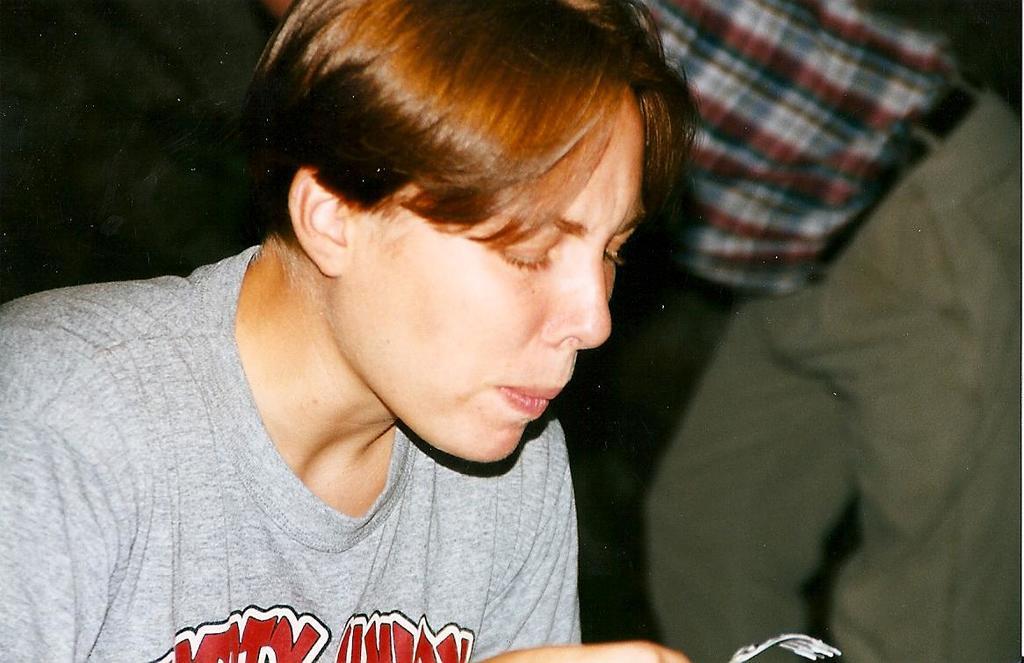Please provide a concise description of this image. In this image, I can see a person holding a fork and there is another person standing. The background is dark. 